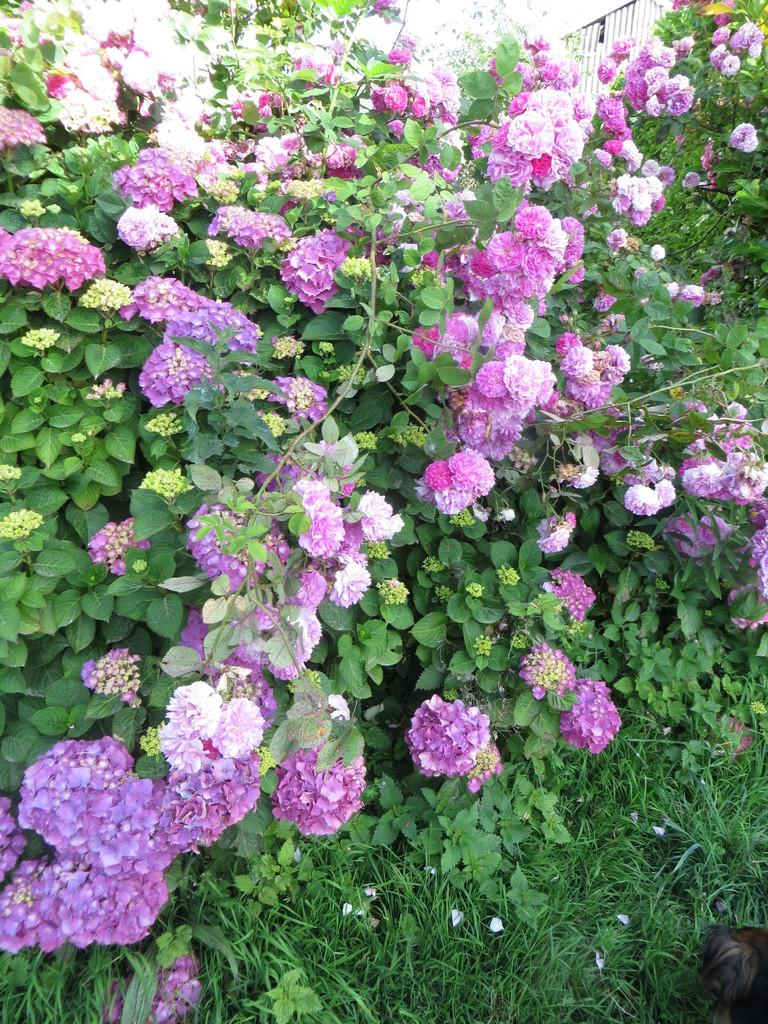What type of plants can be seen in the image? There are plants with flowers in the image. What type of vegetation is visible in the image besides the plants? There is grass visible in the image. What type of star can be seen in the image? There is no star visible in the image; it features plants with flowers and grass. What type of trousers are the plants wearing in the image? Plants do not wear trousers, as they are living organisms and not human beings. 